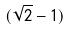Convert formula to latex. <formula><loc_0><loc_0><loc_500><loc_500>( \sqrt { 2 } - 1 )</formula> 